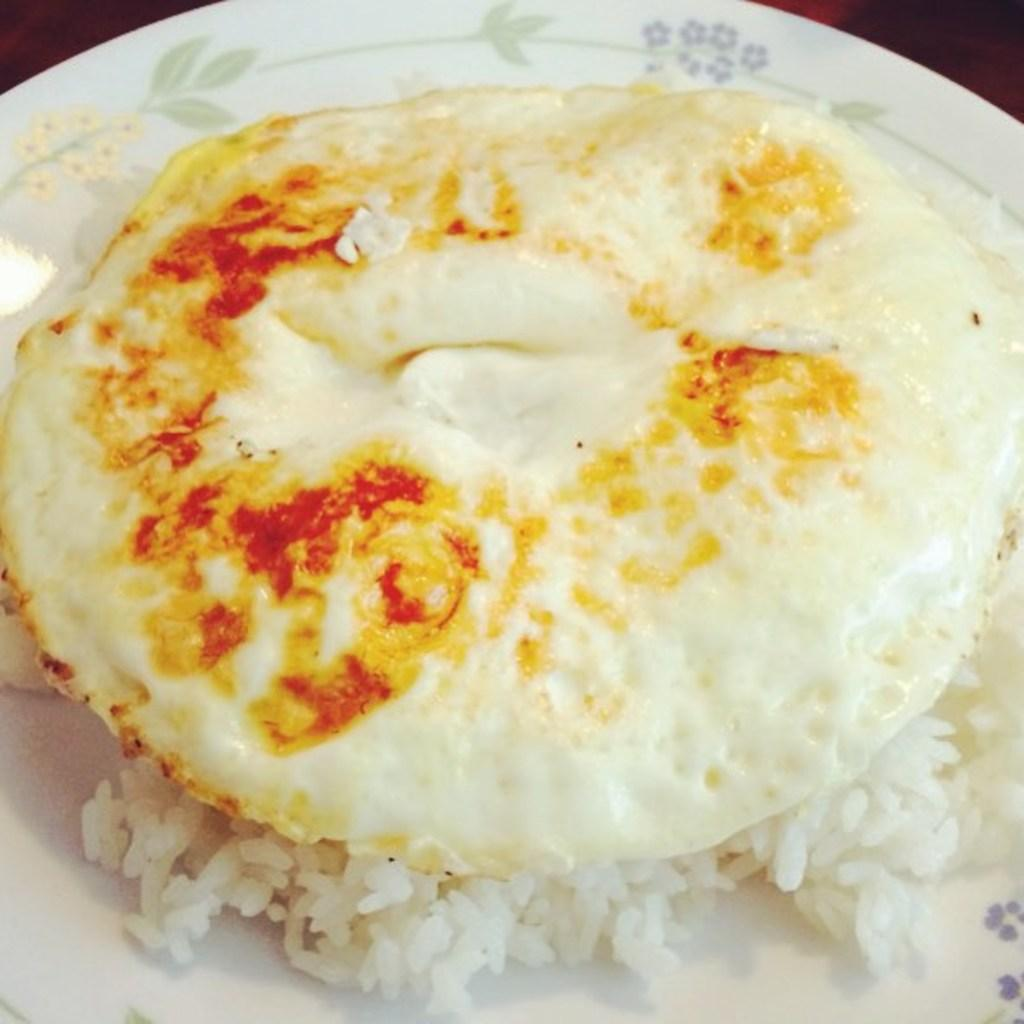What type of food is partially cooked in the image? There is a half-boiled omelette in the image. What other type of food is visible in the image? There is rice in the image. How are the omelette and rice arranged in the image? The omelette and rice are on a plate. What type of toothpaste is visible in the image? There is no toothpaste present in the image. How many bikes are parked next to the plate in the image? There are no bikes present in the image. 